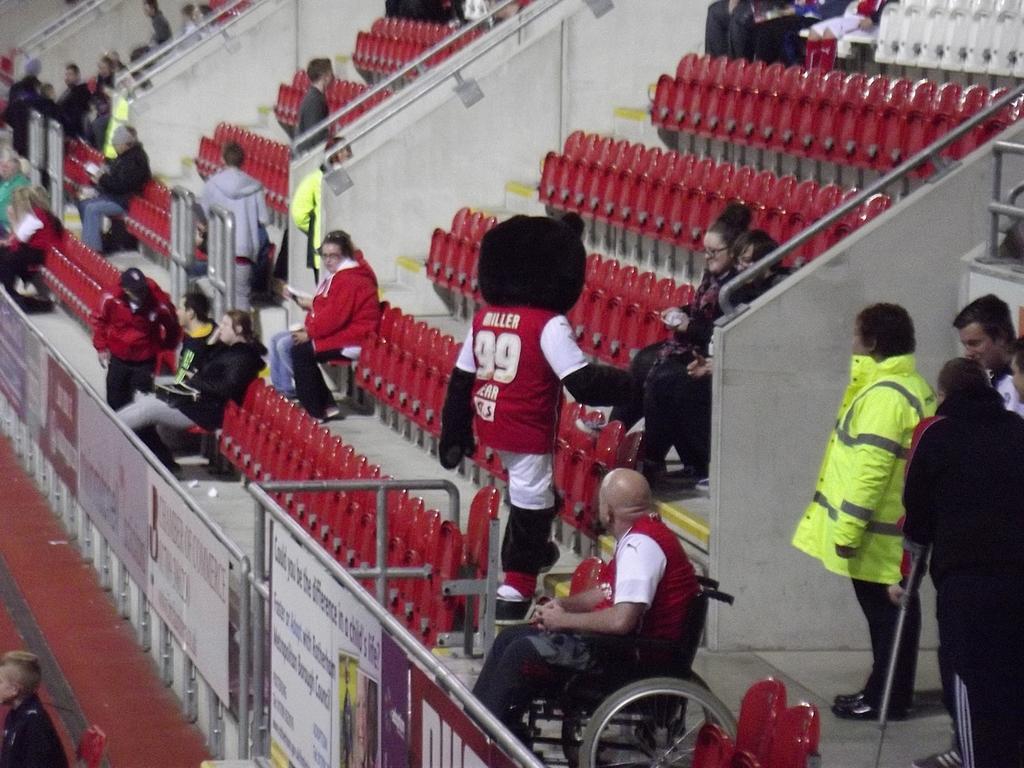In one or two sentences, can you explain what this image depicts? Here we can see few persons and there are chairs. This is floor and there are boards. 